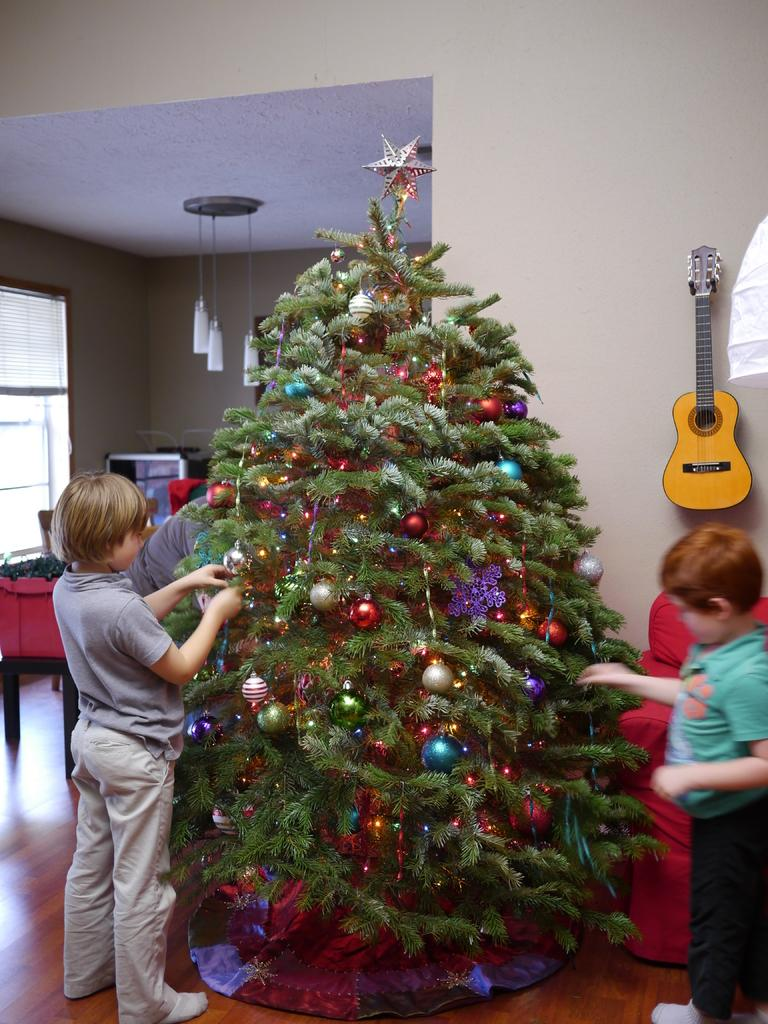What is the main object in the image? There is a Christmas tree in the image. Can you describe the scene in the background? In the background, there are two children, a guitar, a wall, a light, and a window visible. What might be used for musical entertainment in the image? A guitar is visible in the background of the image. What architectural feature is present in the background of the image? There is a window in the background of the image. What type of brass instrument is being played by the children in the image? There are no brass instruments or children playing instruments present in the image. 